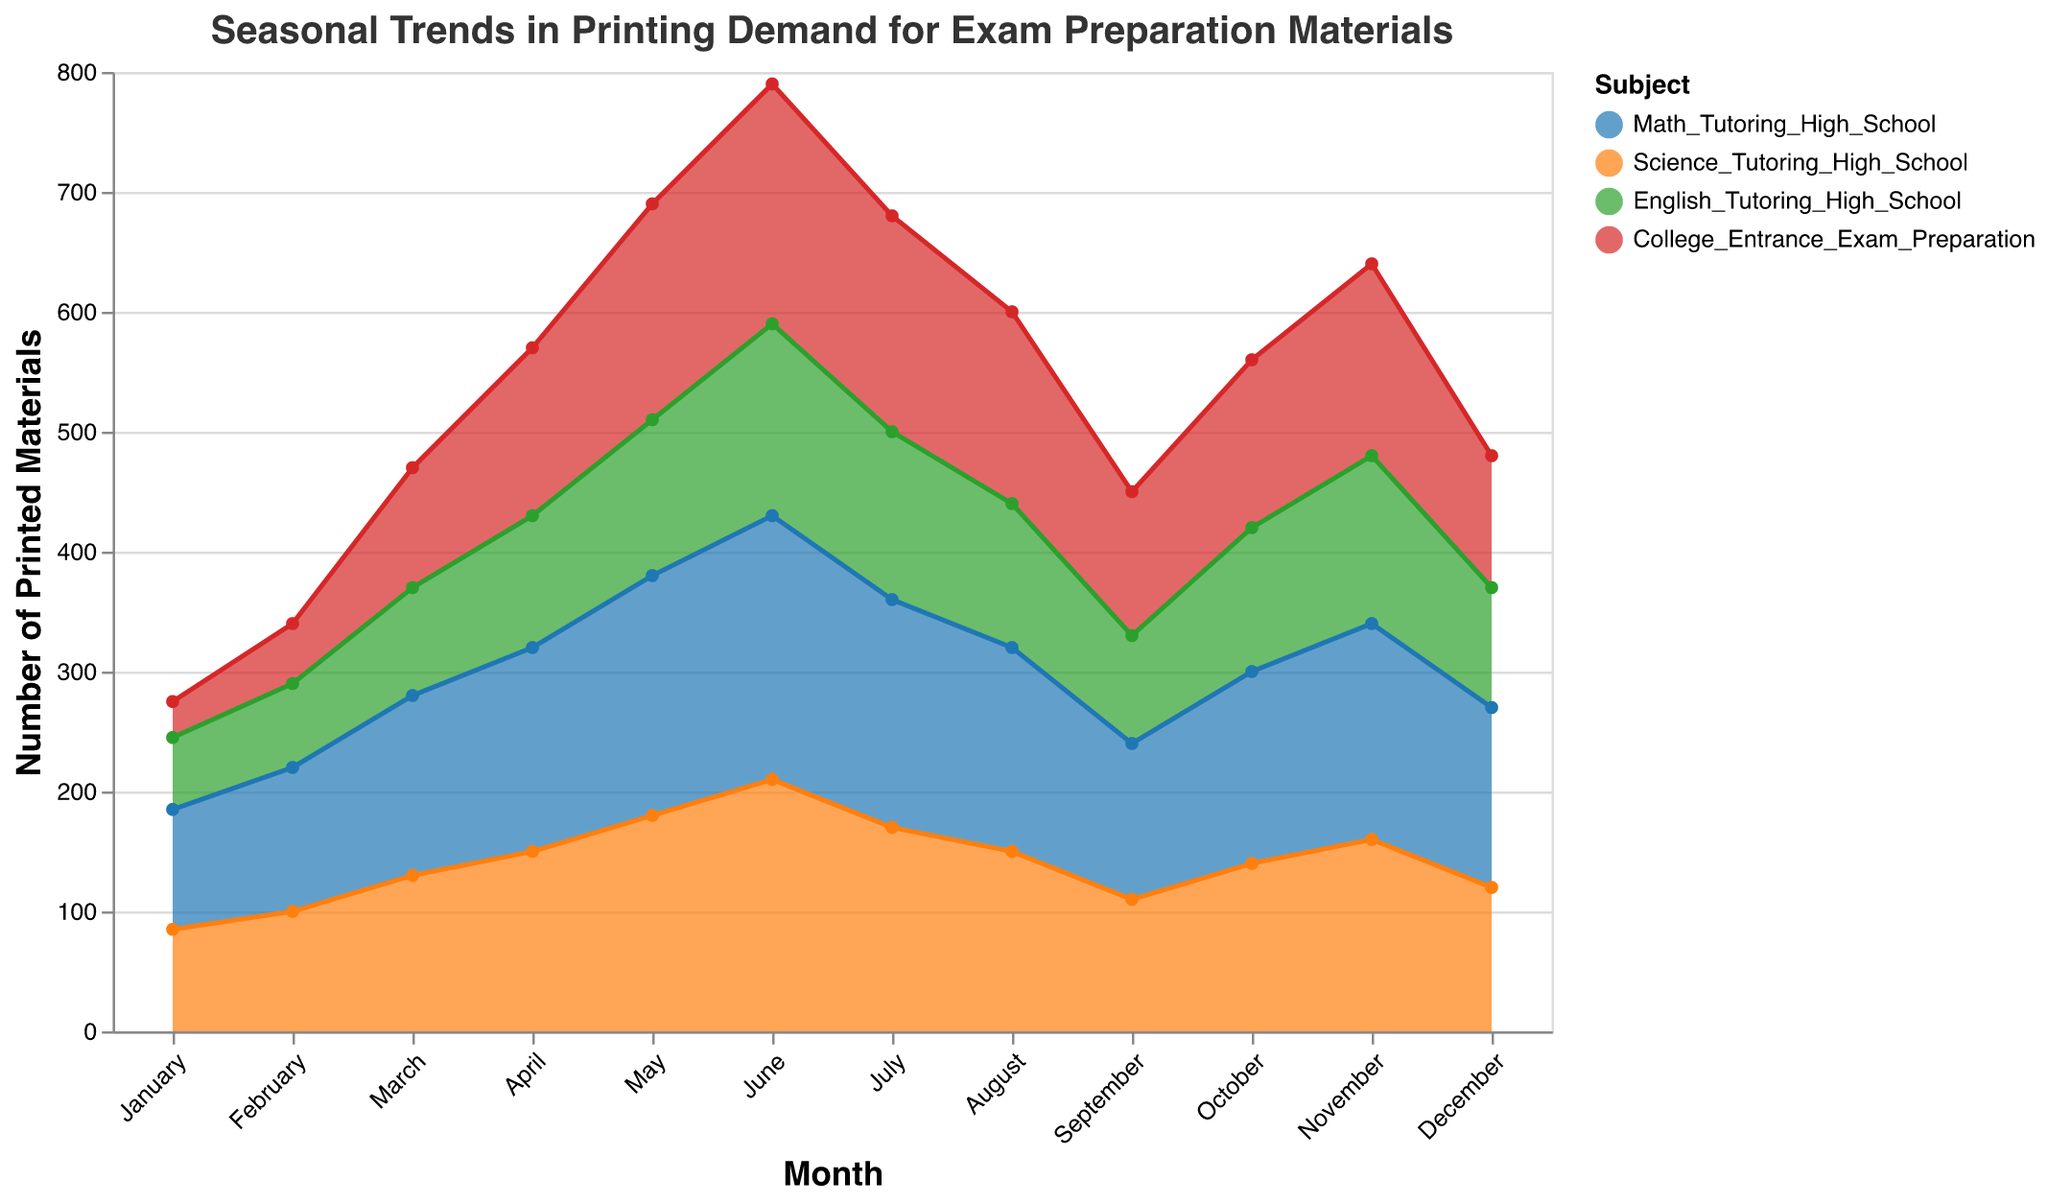What is the title of the chart? The title of the chart is located at the top center. It reads "Seasonal Trends in Printing Demand for Exam Preparation Materials".
Answer: Seasonal Trends in Printing Demand for Exam Preparation Materials Which subject has the highest print demand in June? To determine which subject has the highest print demand in June, look at the data points for June on the y-axis for each subject. The highest data point is for Math Tutoring High School at 220.
Answer: Math Tutoring High School How does the print demand for English Tutoring High School in March compare to May? Compare the data points for English Tutoring High School in March and May. In March, the value is 90, while in May, the value is 130.
Answer: May has higher demand than March What is the combined print demand for Science Tutoring High School and College Entrance Exam Preparation in July? Find the values for Science Tutoring High School and College Entrance Exam Preparation in July and add them together. Science has 170 and College Entrance Exam Preparation has 180. The combined demand is 170 + 180 = 350.
Answer: 350 During which month does Math Tutoring High School see the maximum print demand? Identify the month with the highest value for Math Tutoring High School by following the trend line for Math. The maximum value is 220, which occurs in June.
Answer: June Which months show a decrease in print demand for Science Tutoring High School compared to the previous month? Look at the trend line for Science Tutoring High School and identify the months where the value decreases from the previous month. July to August (170 to 150) and May to June (210 to 170) show a decrease.
Answer: July and August What is the average print demand for College Entrance Exam Preparation over the entire year? Add the monthly values for College Entrance Exam Preparation (30, 50, 100, 140, 180, 200, 180, 160, 120, 140, 160, 110) and divide by 12. The sum is 1570, so the average is 1570/12 = 130.83.
Answer: 130.83 How does print demand for Math Tutoring High School in September compare to October? Compare the values for Math Tutoring High School in September (130) and October (160). October has higher demand.
Answer: October has higher demand In which month does English Tutoring High School reach its lowest print demand? Identify the month with the lowest value for English Tutoring High School by looking at the trend line. The lowest value is 60, which occurs in January.
Answer: January Which subject has a uniform print demand trend throughout the year? By checking the trend lines for uniformity in print demand without large fluctuations, Science Tutoring High School appears the most uniform with consistent trends.
Answer: Science Tutoring High School 